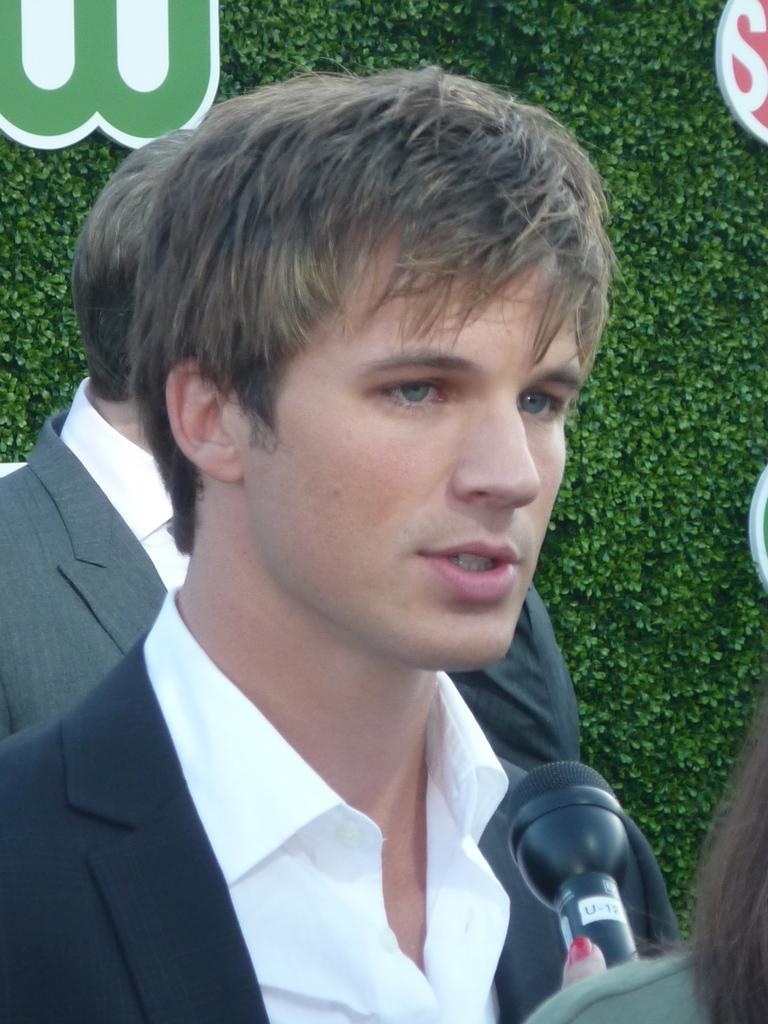Please provide a concise description of this image. In this image, we can see two persons wearing clothes. There is a mic in the bottom right of the image. In the background, we can see some leaves. 